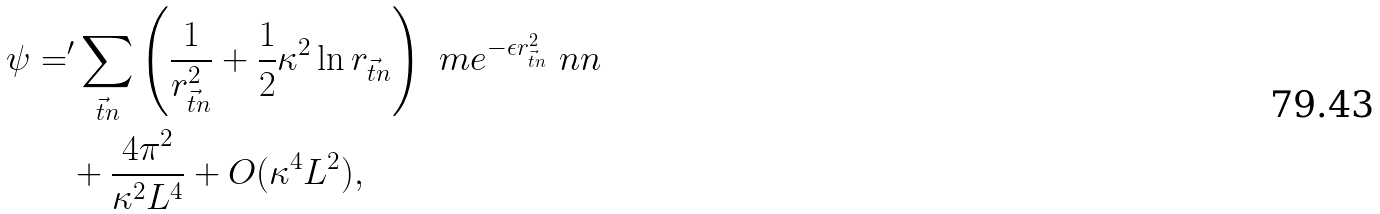<formula> <loc_0><loc_0><loc_500><loc_500>\psi = & { ^ { \prime } } \sum _ { \vec { t } { n } } \left ( \frac { 1 } { r _ { \vec { t } { n } } ^ { 2 } } + \frac { 1 } { 2 } \kappa ^ { 2 } \ln r _ { \vec { t } { n } } \right ) \ m e ^ { - \epsilon r _ { \vec { t } { n } } ^ { 2 } } \ n n \\ & + \frac { 4 \pi ^ { 2 } } { \kappa ^ { 2 } L ^ { 4 } } + O ( \kappa ^ { 4 } L ^ { 2 } ) ,</formula> 